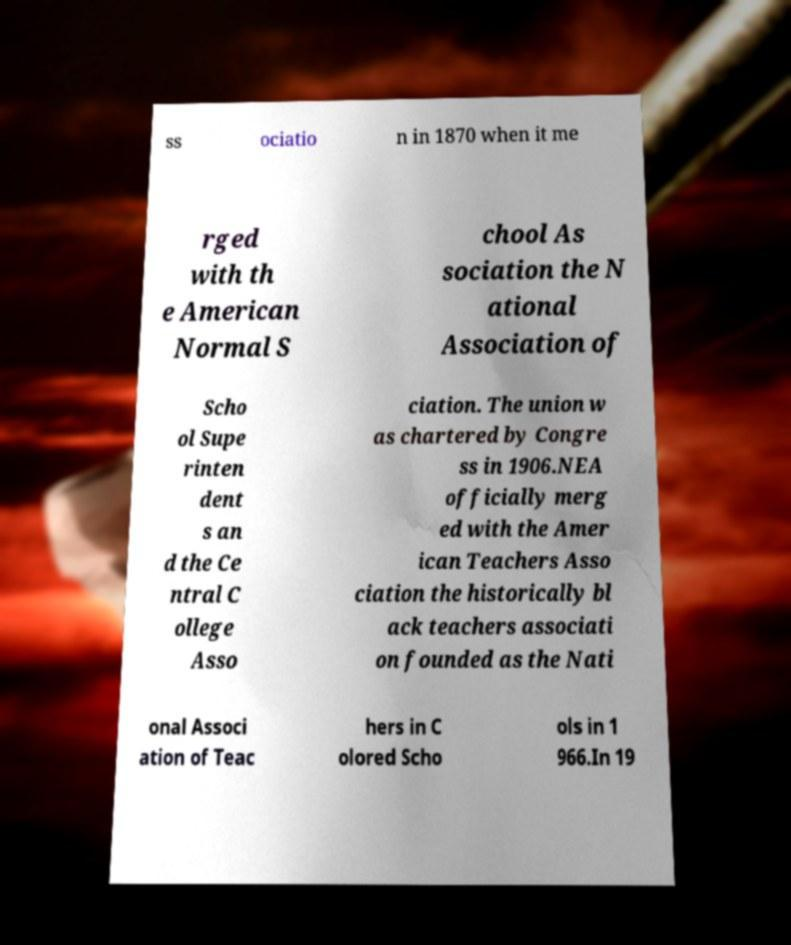Please read and relay the text visible in this image. What does it say? ss ociatio n in 1870 when it me rged with th e American Normal S chool As sociation the N ational Association of Scho ol Supe rinten dent s an d the Ce ntral C ollege Asso ciation. The union w as chartered by Congre ss in 1906.NEA officially merg ed with the Amer ican Teachers Asso ciation the historically bl ack teachers associati on founded as the Nati onal Associ ation of Teac hers in C olored Scho ols in 1 966.In 19 